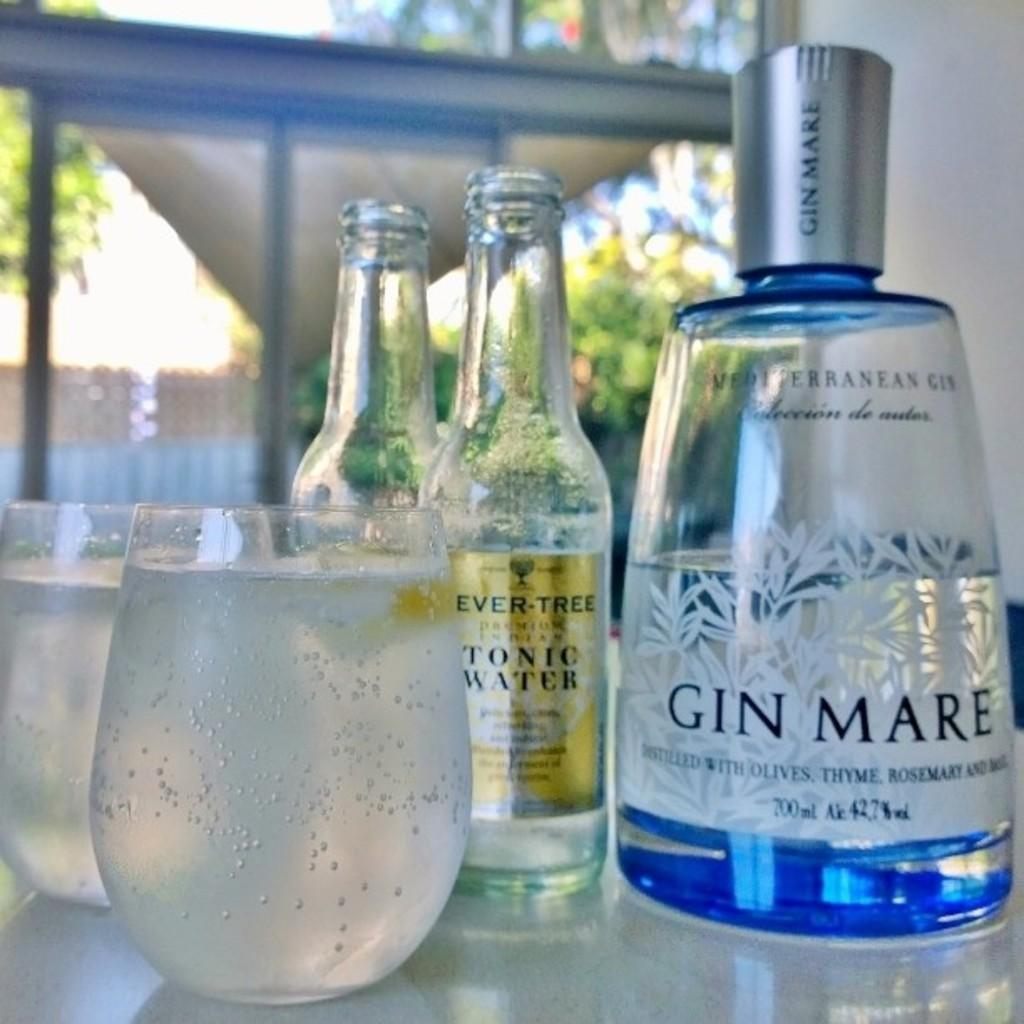<image>
Present a compact description of the photo's key features. Two bottles, two glasses, and a big bottle with the words Gin Mare 